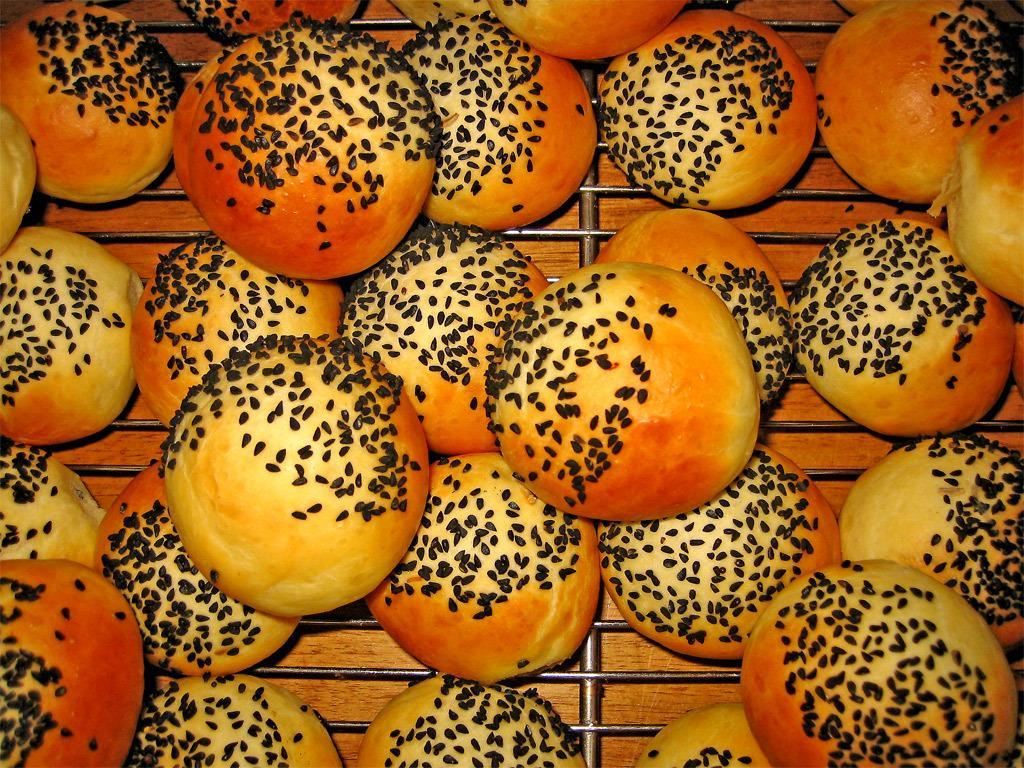Can you describe this image briefly? These are the buns with the sesame seeds on it, which are placed on a grill. In the background, I think this is a wooden table. 